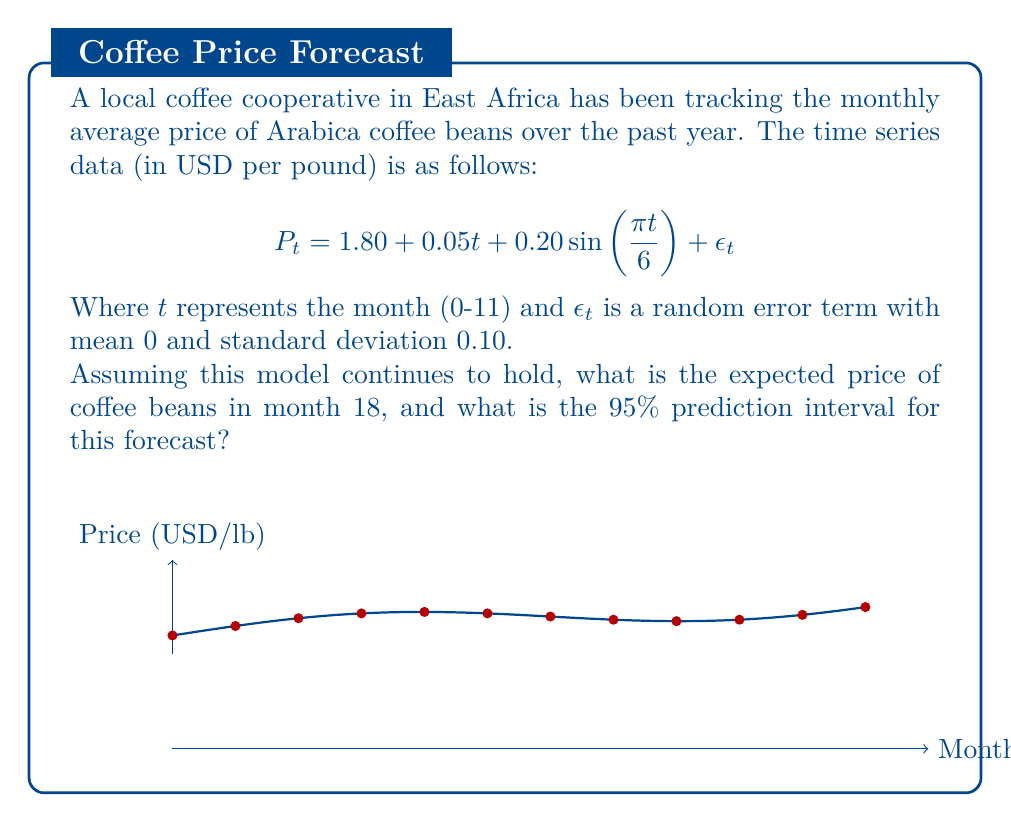What is the answer to this math problem? To solve this problem, we'll follow these steps:

1) First, let's calculate the expected price for month 18:
   
   $$E[P_{18}] = 1.80 + 0.05(18) + 0.20\sin(\frac{\pi 18}{6})$$
   
   $$= 1.80 + 0.90 + 0.20\sin(3\pi)$$
   
   $$= 2.70 + 0 = 2.70$$

2) To calculate the prediction interval, we need to consider the variability introduced by $\epsilon_t$. For a 95% prediction interval, we use 1.96 standard deviations.

3) The standard deviation of $\epsilon_t$ is given as 0.10. Therefore, the 95% prediction interval is:

   $$2.70 \pm 1.96(0.10)$$
   
   $$2.70 \pm 0.196$$

4) This gives us a lower bound of $2.70 - 0.196 = 2.504$ and an upper bound of $2.70 + 0.196 = 2.896$.

Therefore, the expected price in month 18 is $2.70 USD/lb, with a 95% prediction interval of [2.504, 2.896] USD/lb.
Answer: Expected price: $2.70 USD/lb
95% Prediction Interval: [2.504, 2.896] USD/lb 